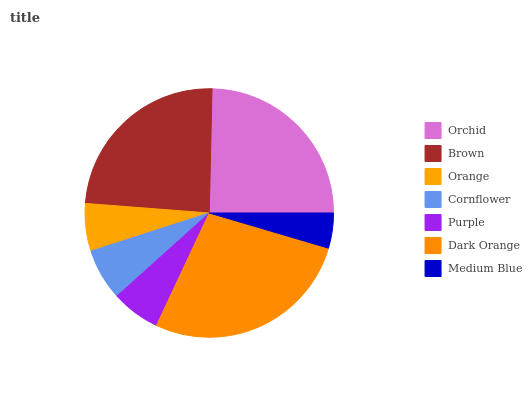Is Medium Blue the minimum?
Answer yes or no. Yes. Is Dark Orange the maximum?
Answer yes or no. Yes. Is Brown the minimum?
Answer yes or no. No. Is Brown the maximum?
Answer yes or no. No. Is Orchid greater than Brown?
Answer yes or no. Yes. Is Brown less than Orchid?
Answer yes or no. Yes. Is Brown greater than Orchid?
Answer yes or no. No. Is Orchid less than Brown?
Answer yes or no. No. Is Cornflower the high median?
Answer yes or no. Yes. Is Cornflower the low median?
Answer yes or no. Yes. Is Brown the high median?
Answer yes or no. No. Is Orange the low median?
Answer yes or no. No. 